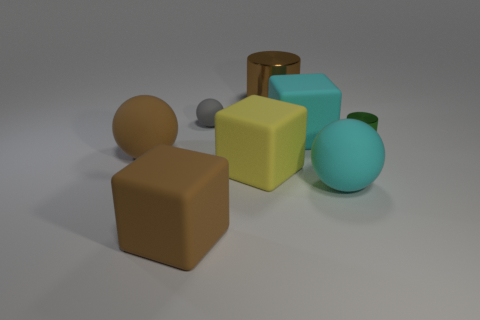Is there anything else that has the same material as the large yellow thing?
Your answer should be very brief. Yes. There is a yellow thing that is made of the same material as the gray object; what is its shape?
Give a very brief answer. Cube. Is the number of gray spheres on the right side of the green shiny cylinder less than the number of large balls that are in front of the yellow object?
Make the answer very short. Yes. What number of large objects are matte spheres or gray balls?
Ensure brevity in your answer.  2. There is a tiny object left of the large yellow matte object; does it have the same shape as the large matte object that is behind the green metal cylinder?
Your answer should be very brief. No. There is a cyan object in front of the sphere on the left side of the rubber object in front of the big cyan rubber ball; what size is it?
Ensure brevity in your answer.  Large. There is a brown object on the right side of the brown rubber block; how big is it?
Keep it short and to the point. Large. What is the small object that is on the left side of the brown metal cylinder made of?
Provide a succinct answer. Rubber. What number of blue objects are either large rubber spheres or spheres?
Keep it short and to the point. 0. Are the gray ball and the big sphere behind the big yellow rubber cube made of the same material?
Offer a terse response. Yes. 